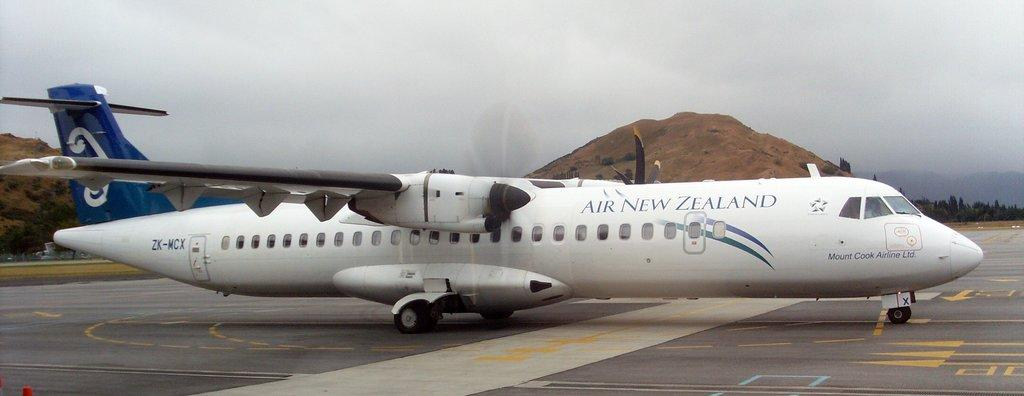What is the main subject of the picture? The main subject of the picture is an aeroplane. What other objects or features can be seen in the picture? There are rocks and trees in the picture. How would you describe the sky in the picture? The sky is cloudy in the picture. What colors are predominantly used in the picture? The colors of the picture are predominantly white and blue. Can you see any twigs on the edge of the battlefield in the image? There is no battlefield or twigs present in the image; it features an aeroplane, rocks, trees, and a cloudy sky. 